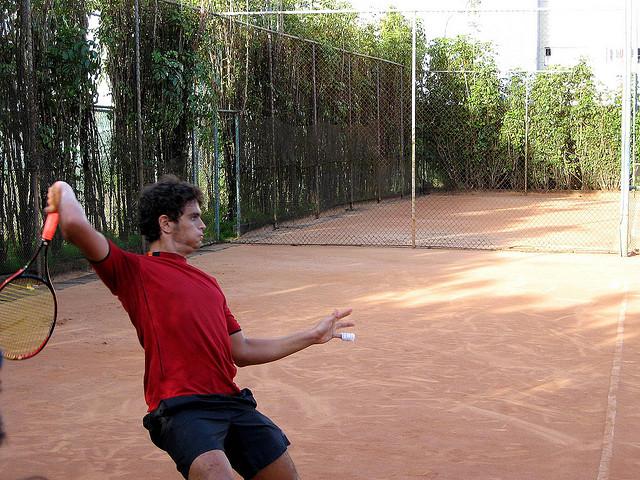What sport is this man playing?
Give a very brief answer. Tennis. Is this a tennis court?
Answer briefly. Yes. Has this man injured his finger?
Give a very brief answer. Yes. 